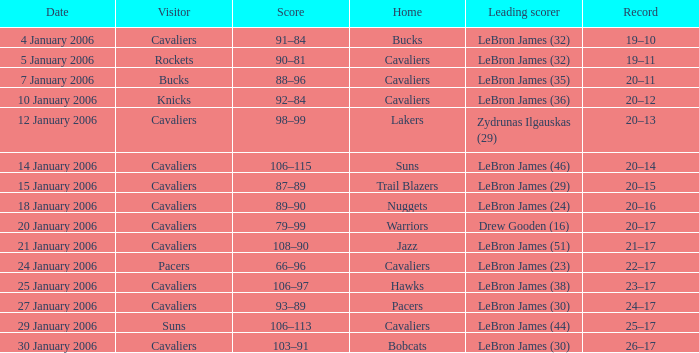In the game at the warriors, who was the top scorer? Drew Gooden (16). 